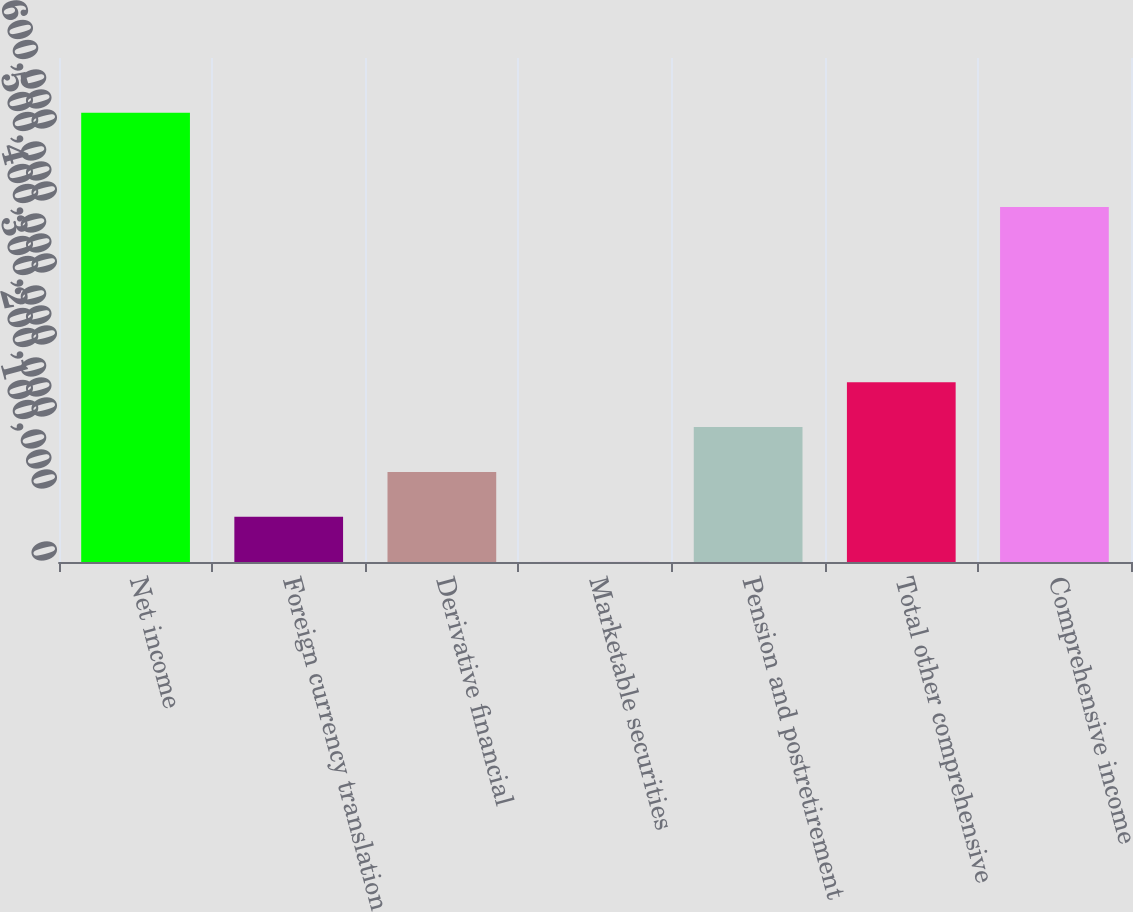Convert chart. <chart><loc_0><loc_0><loc_500><loc_500><bar_chart><fcel>Net income<fcel>Foreign currency translation<fcel>Derivative financial<fcel>Marketable securities<fcel>Pension and postretirement<fcel>Total other comprehensive<fcel>Comprehensive income<nl><fcel>623925<fcel>62707.5<fcel>125065<fcel>350<fcel>187422<fcel>249780<fcel>492980<nl></chart> 